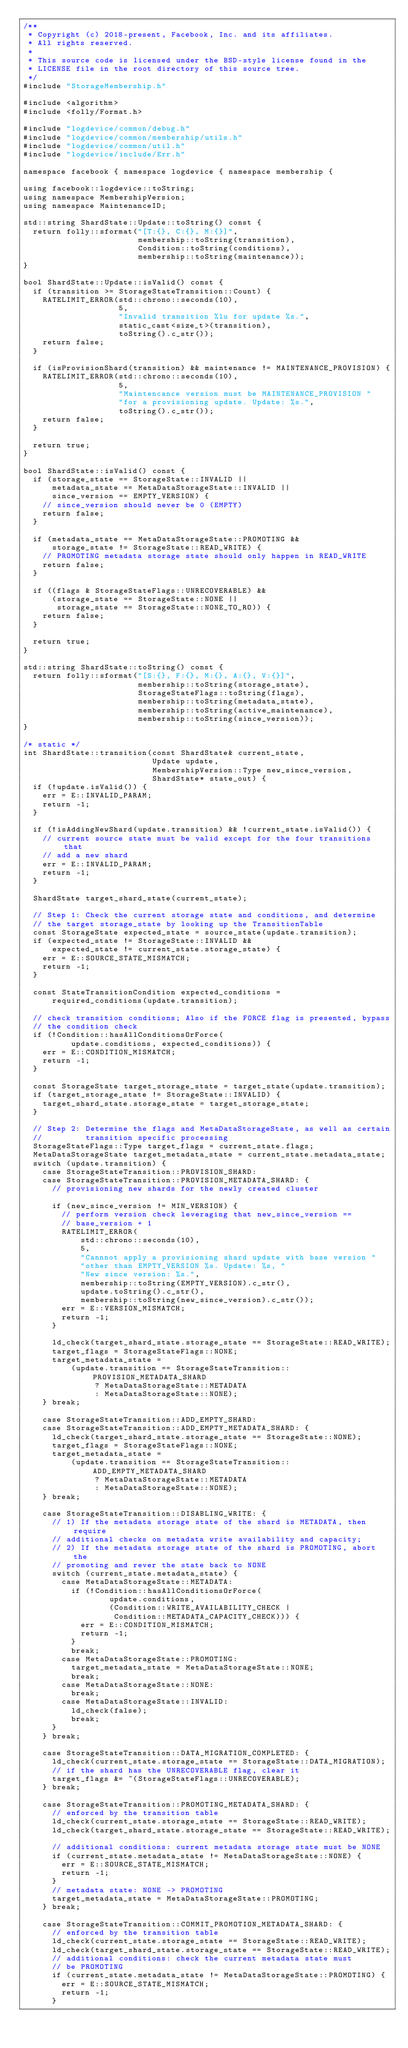<code> <loc_0><loc_0><loc_500><loc_500><_C++_>/**
 * Copyright (c) 2018-present, Facebook, Inc. and its affiliates.
 * All rights reserved.
 *
 * This source code is licensed under the BSD-style license found in the
 * LICENSE file in the root directory of this source tree.
 */
#include "StorageMembership.h"

#include <algorithm>
#include <folly/Format.h>

#include "logdevice/common/debug.h"
#include "logdevice/common/membership/utils.h"
#include "logdevice/common/util.h"
#include "logdevice/include/Err.h"

namespace facebook { namespace logdevice { namespace membership {

using facebook::logdevice::toString;
using namespace MembershipVersion;
using namespace MaintenanceID;

std::string ShardState::Update::toString() const {
  return folly::sformat("[T:{}, C:{}, M:{}]",
                        membership::toString(transition),
                        Condition::toString(conditions),
                        membership::toString(maintenance));
}

bool ShardState::Update::isValid() const {
  if (transition >= StorageStateTransition::Count) {
    RATELIMIT_ERROR(std::chrono::seconds(10),
                    5,
                    "Invalid transition %lu for update %s.",
                    static_cast<size_t>(transition),
                    toString().c_str());
    return false;
  }

  if (isProvisionShard(transition) && maintenance != MAINTENANCE_PROVISION) {
    RATELIMIT_ERROR(std::chrono::seconds(10),
                    5,
                    "Maintencance version must be MAINTENANCE_PROVISION "
                    "for a provisioning update. Update: %s.",
                    toString().c_str());
    return false;
  }

  return true;
}

bool ShardState::isValid() const {
  if (storage_state == StorageState::INVALID ||
      metadata_state == MetaDataStorageState::INVALID ||
      since_version == EMPTY_VERSION) {
    // since_version should never be 0 (EMPTY)
    return false;
  }

  if (metadata_state == MetaDataStorageState::PROMOTING &&
      storage_state != StorageState::READ_WRITE) {
    // PROMOTING metadata storage state should only happen in READ_WRITE
    return false;
  }

  if ((flags & StorageStateFlags::UNRECOVERABLE) &&
      (storage_state == StorageState::NONE ||
       storage_state == StorageState::NONE_TO_RO)) {
    return false;
  }

  return true;
}

std::string ShardState::toString() const {
  return folly::sformat("[S:{}, F:{}, M:{}, A:{}, V:{}]",
                        membership::toString(storage_state),
                        StorageStateFlags::toString(flags),
                        membership::toString(metadata_state),
                        membership::toString(active_maintenance),
                        membership::toString(since_version));
}

/* static */
int ShardState::transition(const ShardState& current_state,
                           Update update,
                           MembershipVersion::Type new_since_version,
                           ShardState* state_out) {
  if (!update.isValid()) {
    err = E::INVALID_PARAM;
    return -1;
  }

  if (!isAddingNewShard(update.transition) && !current_state.isValid()) {
    // current source state must be valid except for the four transitions that
    // add a new shard
    err = E::INVALID_PARAM;
    return -1;
  }

  ShardState target_shard_state(current_state);

  // Step 1: Check the current storage state and conditions, and determine
  // the target storage_state by looking up the TransitionTable
  const StorageState expected_state = source_state(update.transition);
  if (expected_state != StorageState::INVALID &&
      expected_state != current_state.storage_state) {
    err = E::SOURCE_STATE_MISMATCH;
    return -1;
  }

  const StateTransitionCondition expected_conditions =
      required_conditions(update.transition);

  // check transition conditions; Also if the FORCE flag is presented, bypass
  // the condition check
  if (!Condition::hasAllConditionsOrForce(
          update.conditions, expected_conditions)) {
    err = E::CONDITION_MISMATCH;
    return -1;
  }

  const StorageState target_storage_state = target_state(update.transition);
  if (target_storage_state != StorageState::INVALID) {
    target_shard_state.storage_state = target_storage_state;
  }

  // Step 2: Determine the flags and MetaDataStorageState, as well as certain
  //         transition specific processing
  StorageStateFlags::Type target_flags = current_state.flags;
  MetaDataStorageState target_metadata_state = current_state.metadata_state;
  switch (update.transition) {
    case StorageStateTransition::PROVISION_SHARD:
    case StorageStateTransition::PROVISION_METADATA_SHARD: {
      // provisioning new shards for the newly created cluster

      if (new_since_version != MIN_VERSION) {
        // perform version check leveraging that new_since_version ==
        // base_version + 1
        RATELIMIT_ERROR(
            std::chrono::seconds(10),
            5,
            "Cannnot apply a provisioning shard update with base version "
            "other than EMPTY_VERSION %s. Update: %s, "
            "New since version: %s.",
            membership::toString(EMPTY_VERSION).c_str(),
            update.toString().c_str(),
            membership::toString(new_since_version).c_str());
        err = E::VERSION_MISMATCH;
        return -1;
      }

      ld_check(target_shard_state.storage_state == StorageState::READ_WRITE);
      target_flags = StorageStateFlags::NONE;
      target_metadata_state =
          (update.transition == StorageStateTransition::PROVISION_METADATA_SHARD
               ? MetaDataStorageState::METADATA
               : MetaDataStorageState::NONE);
    } break;

    case StorageStateTransition::ADD_EMPTY_SHARD:
    case StorageStateTransition::ADD_EMPTY_METADATA_SHARD: {
      ld_check(target_shard_state.storage_state == StorageState::NONE);
      target_flags = StorageStateFlags::NONE;
      target_metadata_state =
          (update.transition == StorageStateTransition::ADD_EMPTY_METADATA_SHARD
               ? MetaDataStorageState::METADATA
               : MetaDataStorageState::NONE);
    } break;

    case StorageStateTransition::DISABLING_WRITE: {
      // 1) If the metadata storage state of the shard is METADATA, then require
      // additional checks on metadata write availability and capacity;
      // 2) If the metadata storage state of the shard is PROMOTING, abort the
      // promoting and rever the state back to NONE
      switch (current_state.metadata_state) {
        case MetaDataStorageState::METADATA:
          if (!Condition::hasAllConditionsOrForce(
                  update.conditions,
                  (Condition::WRITE_AVAILABILITY_CHECK |
                   Condition::METADATA_CAPACITY_CHECK))) {
            err = E::CONDITION_MISMATCH;
            return -1;
          }
          break;
        case MetaDataStorageState::PROMOTING:
          target_metadata_state = MetaDataStorageState::NONE;
          break;
        case MetaDataStorageState::NONE:
          break;
        case MetaDataStorageState::INVALID:
          ld_check(false);
          break;
      }
    } break;

    case StorageStateTransition::DATA_MIGRATION_COMPLETED: {
      ld_check(current_state.storage_state == StorageState::DATA_MIGRATION);
      // if the shard has the UNRECOVERABLE flag, clear it
      target_flags &= ~(StorageStateFlags::UNRECOVERABLE);
    } break;

    case StorageStateTransition::PROMOTING_METADATA_SHARD: {
      // enforced by the transition table
      ld_check(current_state.storage_state == StorageState::READ_WRITE);
      ld_check(target_shard_state.storage_state == StorageState::READ_WRITE);

      // additional conditions: current metadata storage state must be NONE
      if (current_state.metadata_state != MetaDataStorageState::NONE) {
        err = E::SOURCE_STATE_MISMATCH;
        return -1;
      }
      // metadata state: NONE -> PROMOTING
      target_metadata_state = MetaDataStorageState::PROMOTING;
    } break;

    case StorageStateTransition::COMMIT_PROMOTION_METADATA_SHARD: {
      // enforced by the transition table
      ld_check(current_state.storage_state == StorageState::READ_WRITE);
      ld_check(target_shard_state.storage_state == StorageState::READ_WRITE);
      // additional conditions: check the current metadata state must
      // be PROMOTING
      if (current_state.metadata_state != MetaDataStorageState::PROMOTING) {
        err = E::SOURCE_STATE_MISMATCH;
        return -1;
      }</code> 